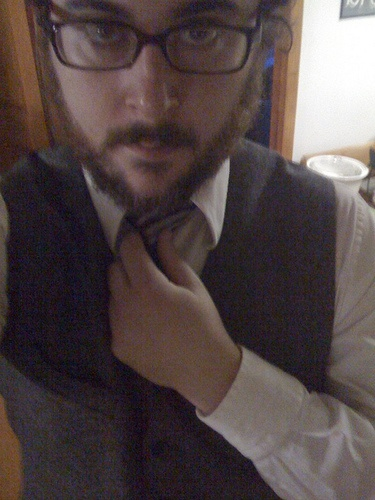Describe the objects in this image and their specific colors. I can see people in black, gray, olive, and maroon tones, cup in olive, lightgray, and darkgray tones, and tie in olive, black, and gray tones in this image. 